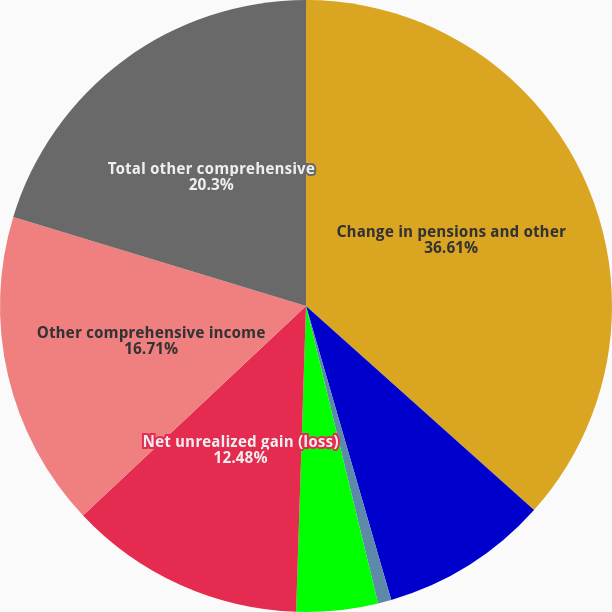Convert chart. <chart><loc_0><loc_0><loc_500><loc_500><pie_chart><fcel>Change in pensions and other<fcel>Foreign currency translation<fcel>Holding gain (loss)<fcel>Reclassification of realized<fcel>Net unrealized gain (loss)<fcel>Other comprehensive income<fcel>Total other comprehensive<nl><fcel>36.62%<fcel>8.89%<fcel>0.71%<fcel>4.3%<fcel>12.48%<fcel>16.71%<fcel>20.3%<nl></chart> 